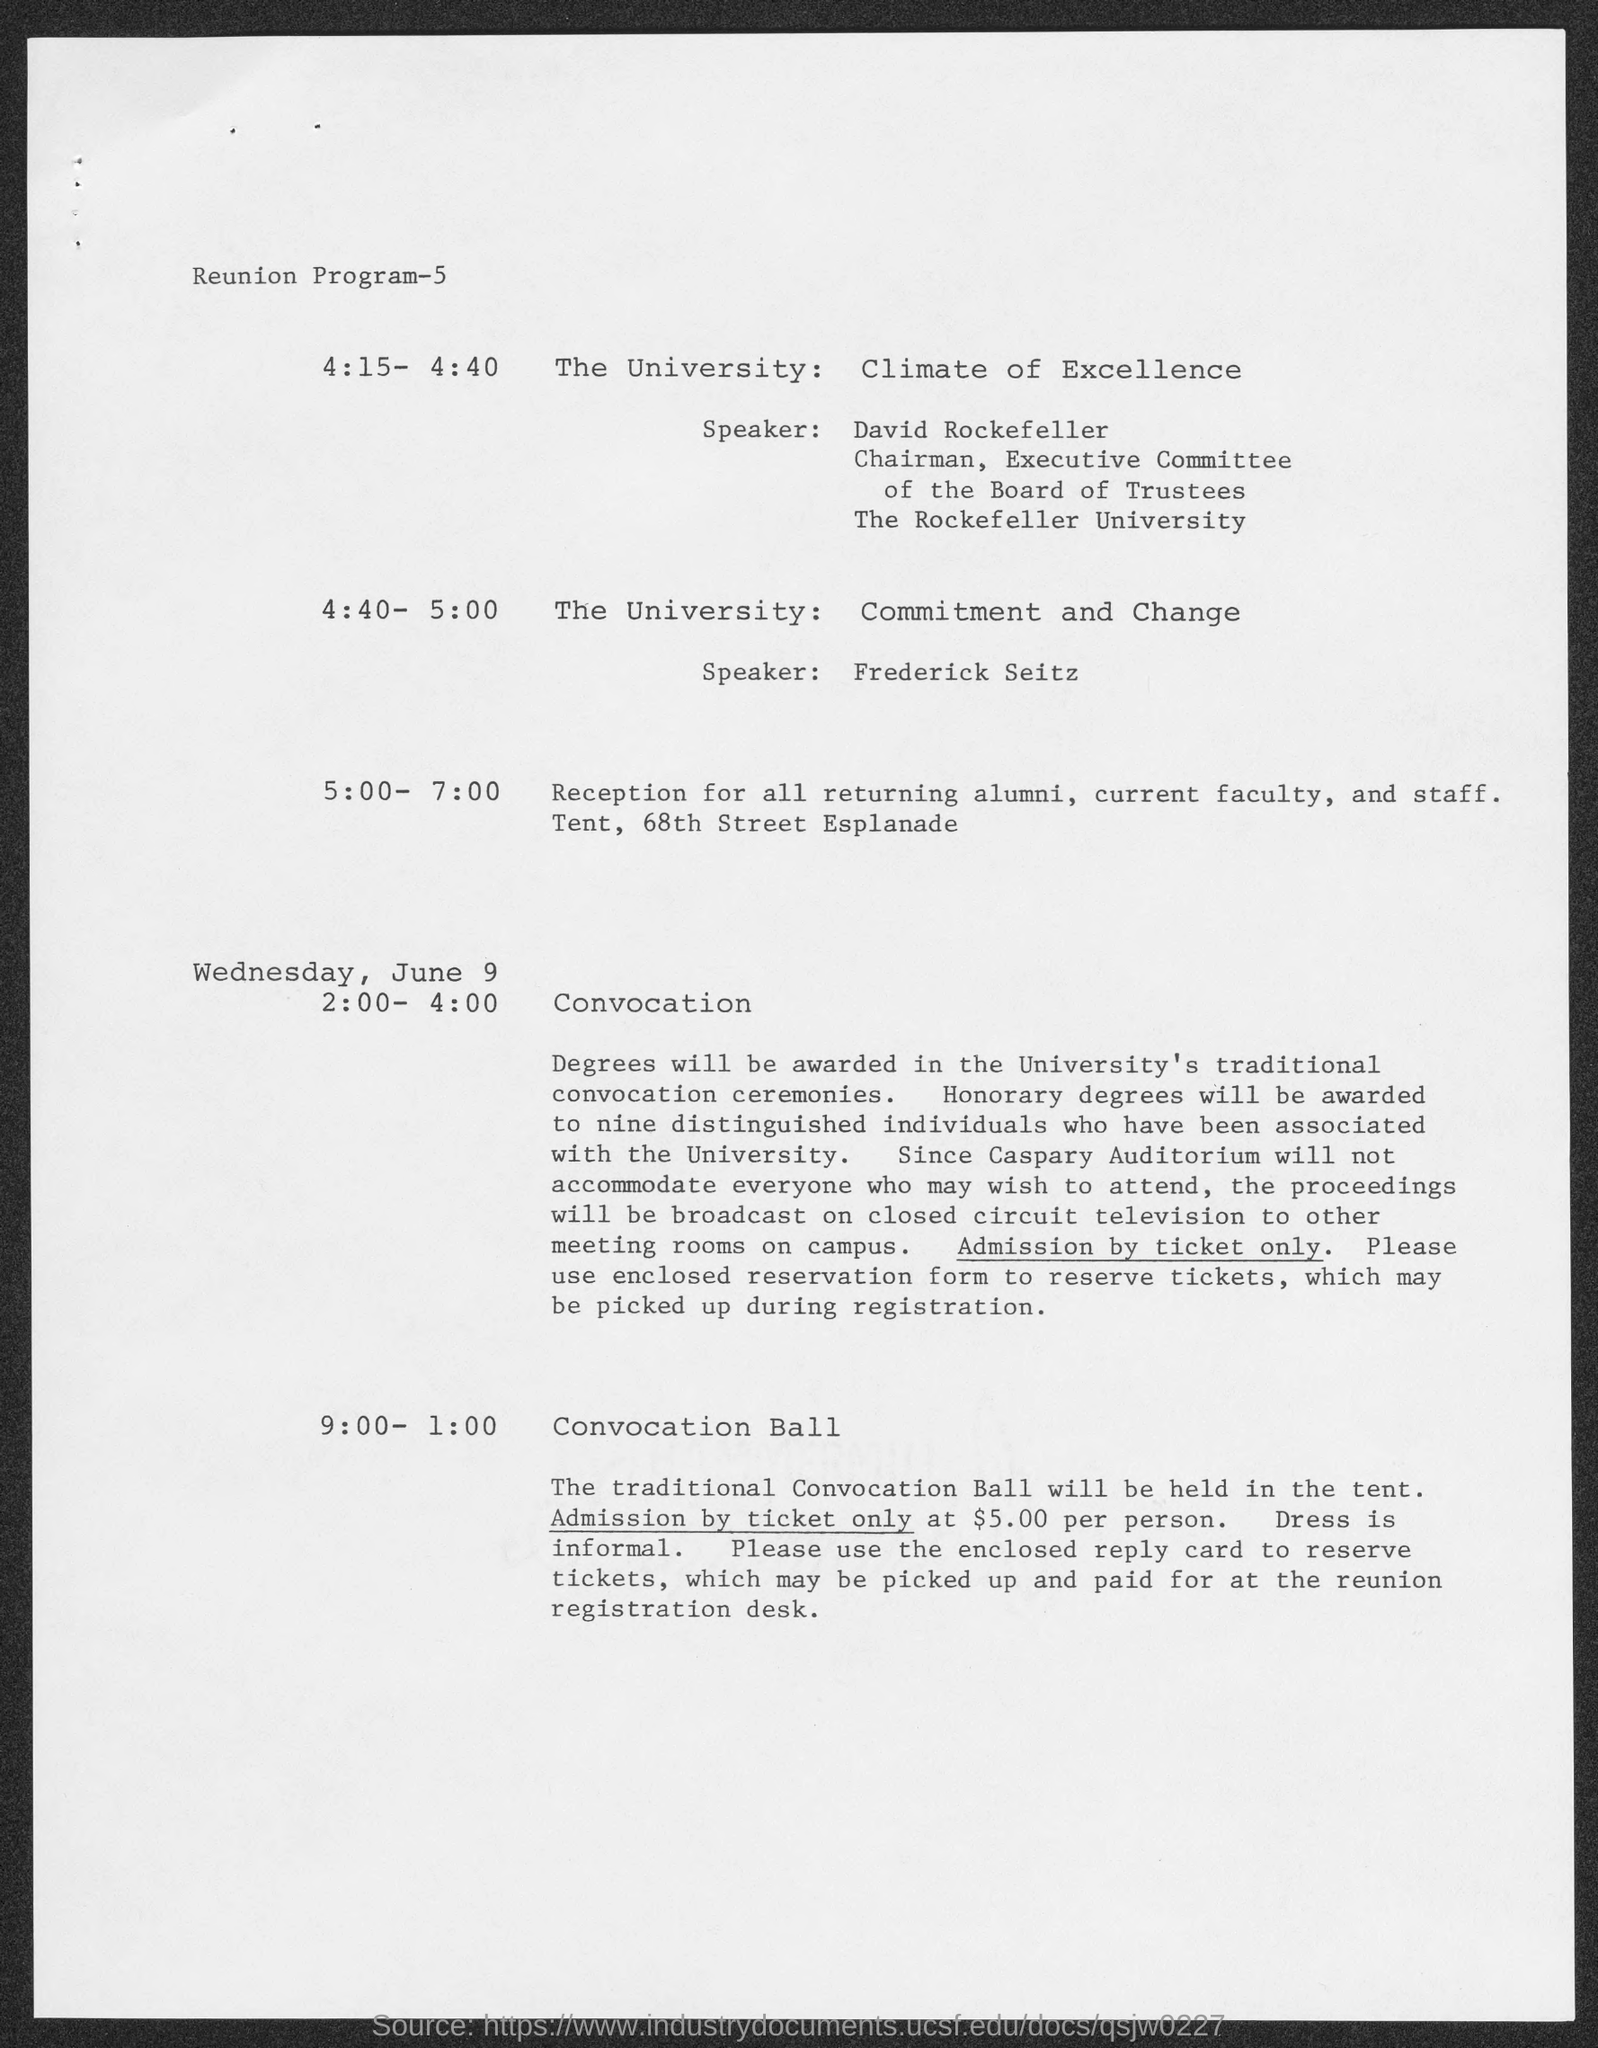Who is the speaker for the university : climate of excellence?
Offer a terse response. David Rockefeller. To which university does david rockefeller belong?
Your response must be concise. The Rockefeller University. Who is the speaker for the university : commitment and change?
Offer a terse response. Frederick seitz. 